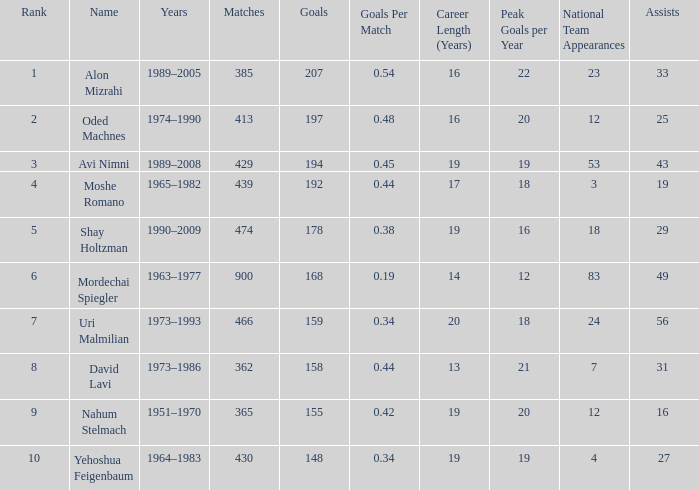What is the Rank of the player with 362 Matches? 8.0. 